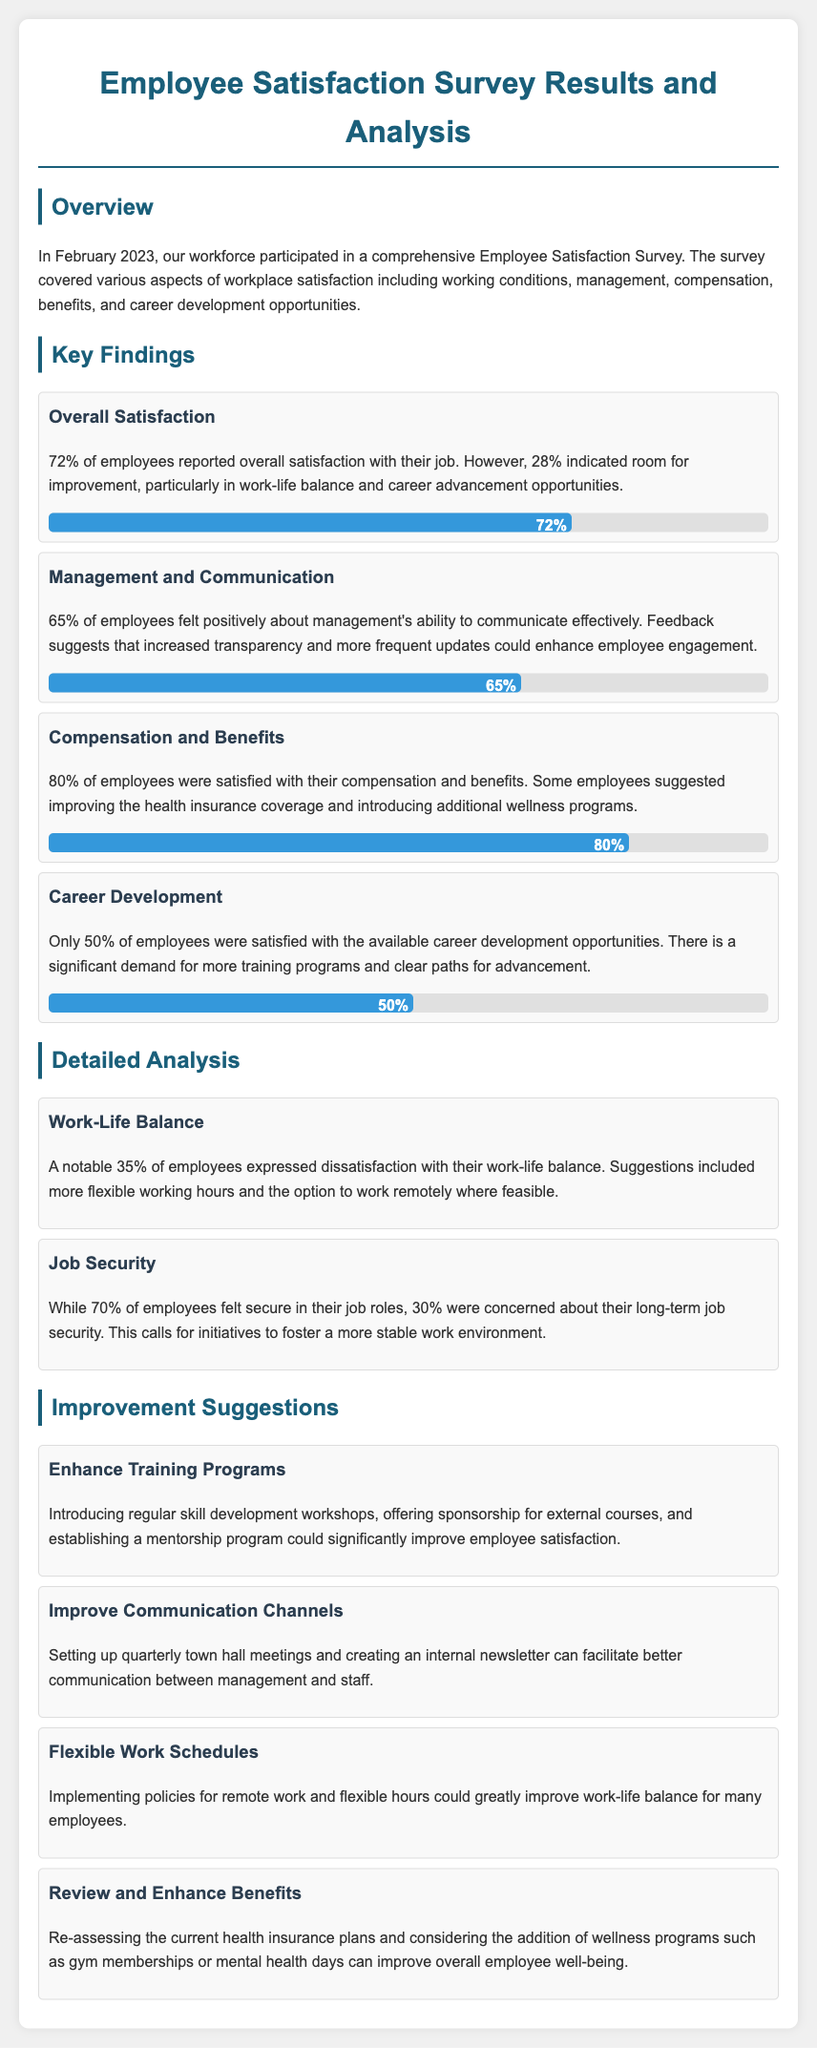What percentage of employees reported overall satisfaction? The document states that 72% of employees reported overall satisfaction with their job.
Answer: 72% What aspect of employee satisfaction received the highest percentage of satisfaction? The document indicates that 80% of employees were satisfied with their compensation and benefits.
Answer: Compensation and benefits What was the percentage of employees that indicated dissatisfaction with work-life balance? It is mentioned that a notable 35% of employees expressed dissatisfaction with their work-life balance.
Answer: 35% Which job satisfaction aspect had only 50% satisfaction? The document highlights that only 50% of employees were satisfied with the available career development opportunities.
Answer: Career development What improvement suggestion involves changing work schedules? The document suggests implementing policies for remote work and flexible hours to improve work-life balance.
Answer: Flexible Work Schedules How many employees felt secure in their job roles? According to the document, 70% of employees felt secure in their job roles.
Answer: 70% What is a suggested method to enhance communication with staff? The document recommends setting up quarterly town hall meetings as a method to improve communication.
Answer: Quarterly town hall meetings What percentage of employees were satisfied with management's communication? The document mentions that 65% of employees felt positively about management's ability to communicate effectively.
Answer: 65% 